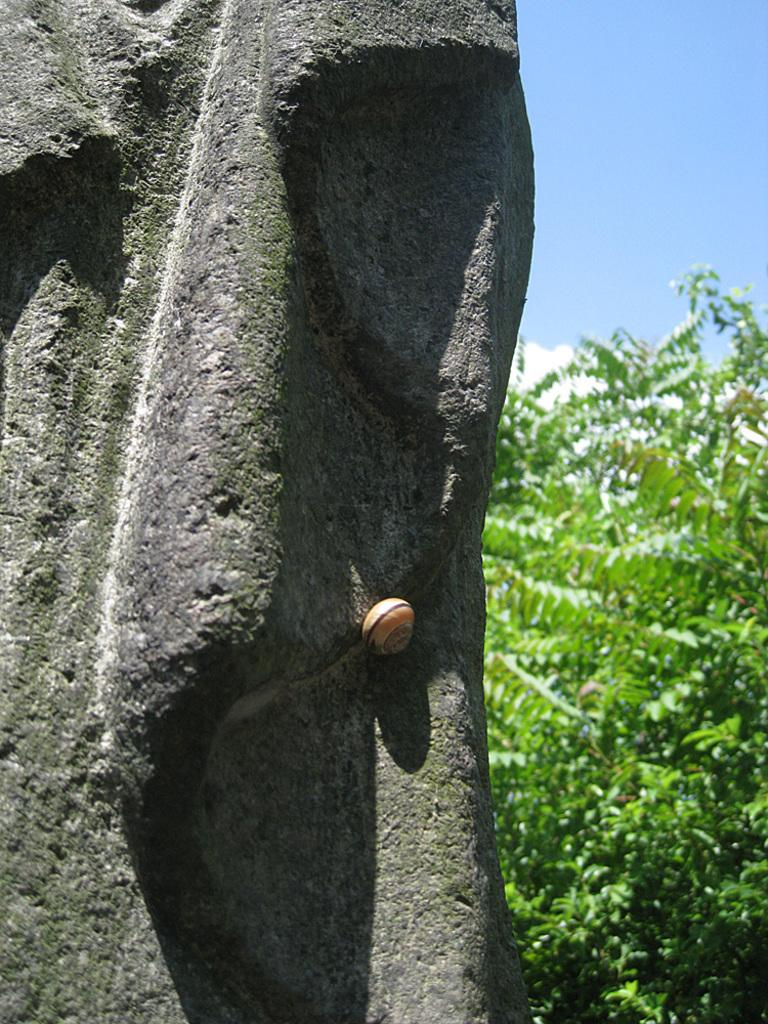What is located on the left side of the image? There is a stone sculpture on the left side of the image. What type of vegetation is on the right side of the image? There are trees on the right side of the image. What color is the sky in the background of the image? The sky is blue in the background of the image. What else can be seen in the sky? Clouds are visible in the sky. Can you see the tail of the hen in the image? There is no hen present in the image, so there is no tail to see. What direction is the sun facing in the image? The image does not show the sun, so it is not possible to determine its direction. 